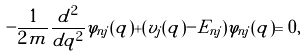Convert formula to latex. <formula><loc_0><loc_0><loc_500><loc_500>- \frac { 1 } { 2 m } \frac { d ^ { 2 } } { d q ^ { 2 } } \varphi _ { n j } ( q ) + ( v _ { j } ( q ) - E _ { n j } ) \varphi _ { n j } ( q ) = 0 ,</formula> 